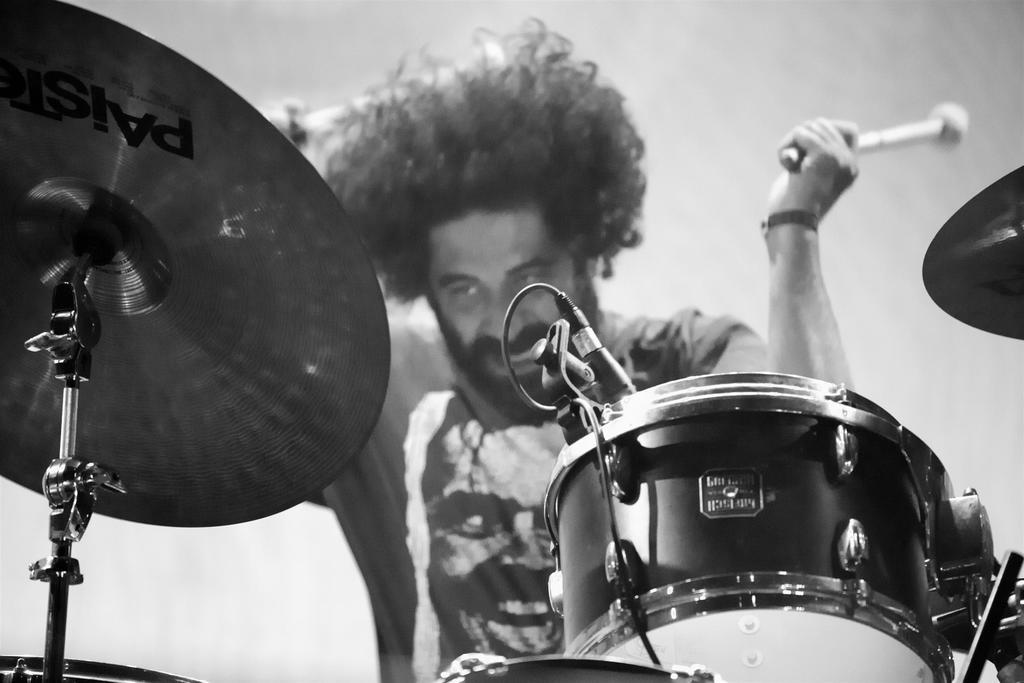What is the color scheme of the image? The image is in black and white. What musical instrument is present in the image? There are electronic drums in the image. Can you describe the person in the background of the image? The person is wearing a t-shirt and holding sticks in his hand. Where is the park located in the image? There is no park present in the image. What type of angle is the mom using to play the drums in the image? There is no mom present in the image, and the person playing the drums is not using any specific angle. 